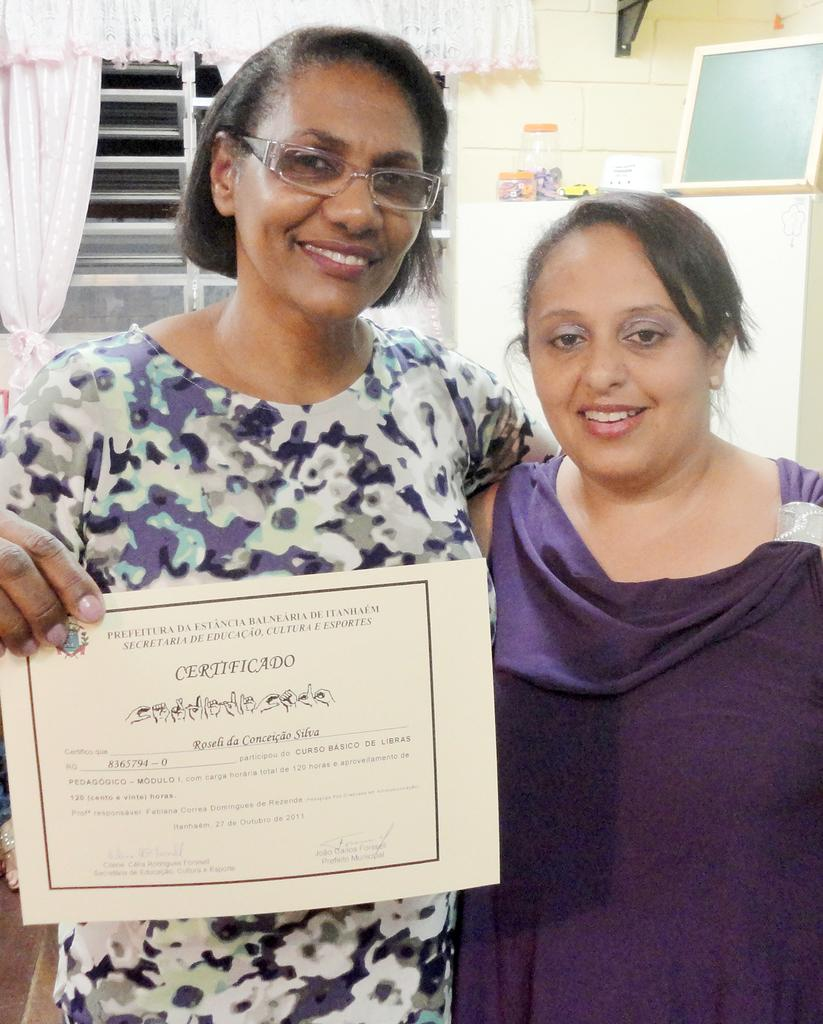How many people are in the image? There are two persons standing and smiling in the image. What is one of the persons holding in the image? There is a person holding a certificate in the image. What can be seen in the background of the image? There is a board, boxes, a window, and curtains associated with the window in the background of the image. What type of night activity is the kitty participating in, as seen in the image? There is no kitty present in the image, so it is not possible to answer that question. --- Facts: 1. There is a person holding a book in the image. 2. The person is sitting on a chair. 3. There is a table in front of the person. 4. There is a lamp on the table. 5. The background of the image is a wall. Absurd Topics: ocean, parrot, bicycle Conversation: What is the person holding in the image? The person is holding a book in the image. What is the person sitting on in the image? The person is sitting on a chair in the image. What object is in front of the person? There is a table in front of the person in the image. What is on the table in the image? There is a lamp on the table in the image. What can be seen behind the person in the image? The background of the image is a wall. Reasoning: Let's think step by step in order to produce the conversation. We start by identifying the main subject in the image, which is the person holding a book. Then, we expand the conversation to include the person's sitting position, the table in front of them, the lamp on the table, and the wall in the background. Each question is designed to elicit a specific detail about the image that is known from the provided facts. Absurd Question/Answer: Can you describe the ocean view from the bicycle in the image? There is no ocean or bicycle present in the image, so it is not possible to answer that question. 